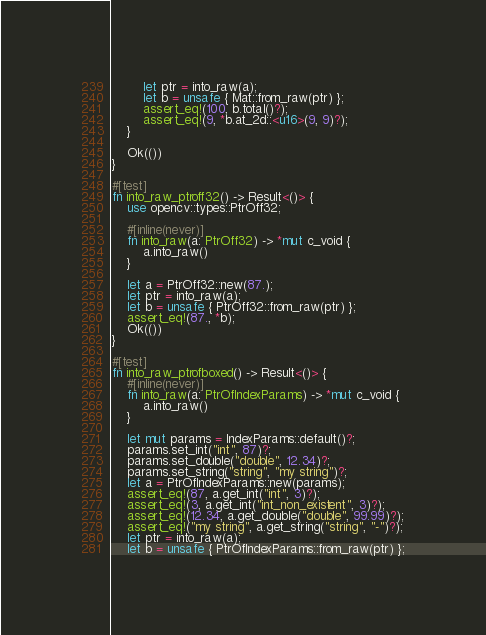Convert code to text. <code><loc_0><loc_0><loc_500><loc_500><_Rust_>		let ptr = into_raw(a);
		let b = unsafe { Mat::from_raw(ptr) };
		assert_eq!(100, b.total()?);
		assert_eq!(9, *b.at_2d::<u16>(9, 9)?);
	}

	Ok(())
}

#[test]
fn into_raw_ptroff32() -> Result<()> {
	use opencv::types::PtrOff32;

	#[inline(never)]
	fn into_raw(a: PtrOff32) -> *mut c_void {
		a.into_raw()
	}

	let a = PtrOff32::new(87.);
	let ptr = into_raw(a);
	let b = unsafe { PtrOff32::from_raw(ptr) };
	assert_eq!(87., *b);
	Ok(())
}

#[test]
fn into_raw_ptrofboxed() -> Result<()> {
	#[inline(never)]
	fn into_raw(a: PtrOfIndexParams) -> *mut c_void {
		a.into_raw()
	}

	let mut params = IndexParams::default()?;
	params.set_int("int", 87)?;
	params.set_double("double", 12.34)?;
	params.set_string("string", "my string")?;
	let a = PtrOfIndexParams::new(params);
	assert_eq!(87, a.get_int("int", 3)?);
	assert_eq!(3, a.get_int("int_non_existent", 3)?);
	assert_eq!(12.34, a.get_double("double", 99.99)?);
	assert_eq!("my string", a.get_string("string", "-")?);
	let ptr = into_raw(a);
	let b = unsafe { PtrOfIndexParams::from_raw(ptr) };</code> 